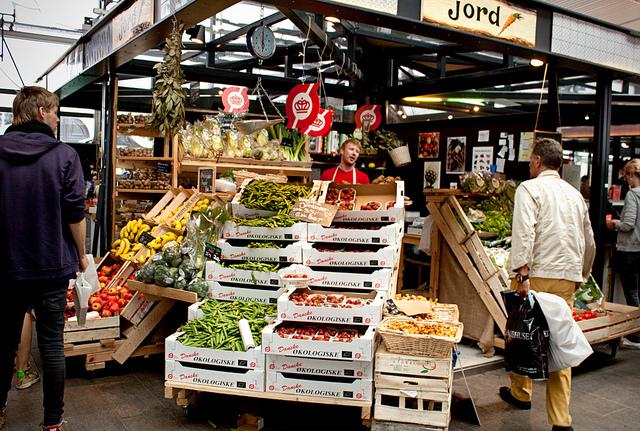What is the yellow fruit on the left?
Concise answer only. Bananas. Where is this?
Short answer required. Market. Are there both fruits and vegetables on display?
Keep it brief. Yes. 